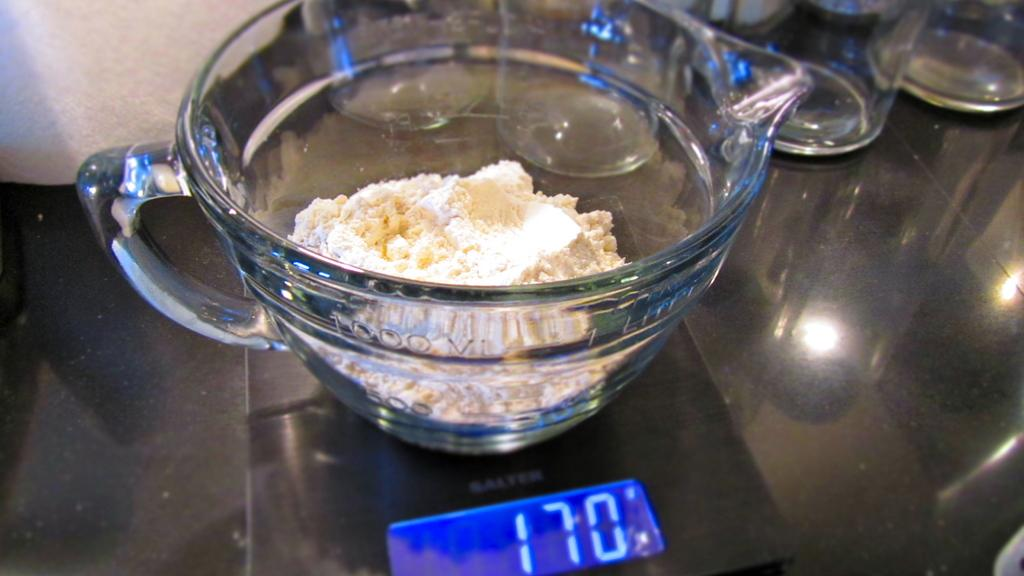<image>
Write a terse but informative summary of the picture. A baking scale readout says the ingredient weighs 170. 